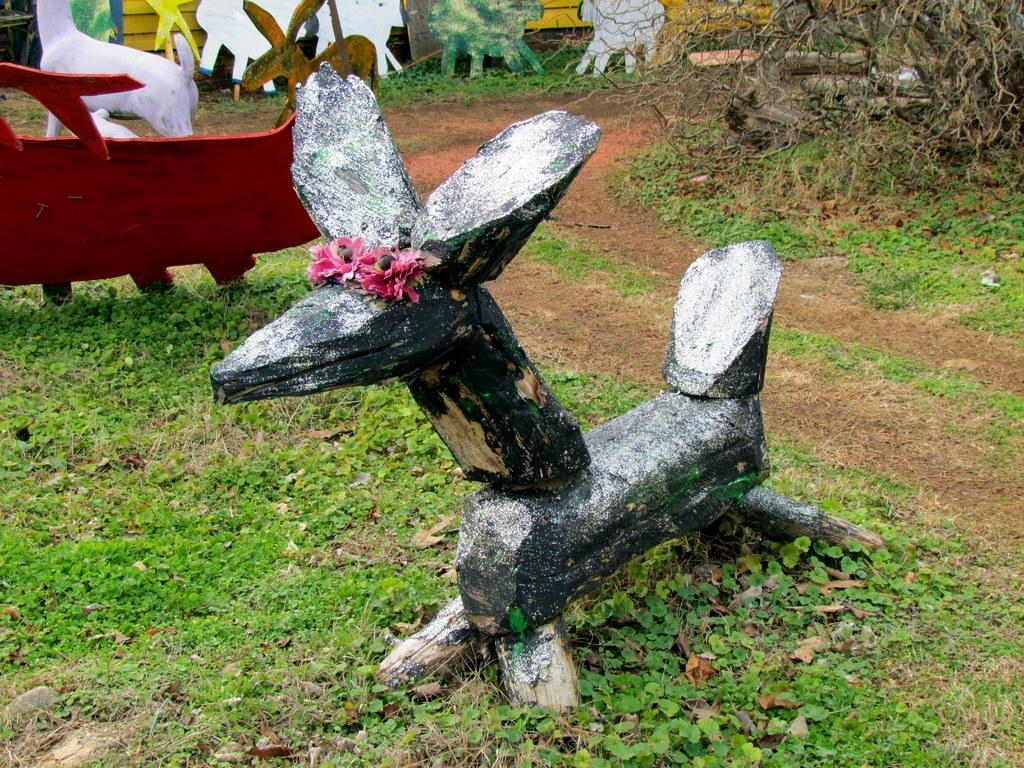What is the main subject of the image? There is an object in the image, which is grass. What else can be seen in the image besides the grass? There is a path, tree branches, and a flower in the image. Can you describe the flower in the image? The flower is pink in color. How many steps does the car take in the image? There is no car present in the image, so it is not possible to determine how many steps it might take. 